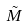<formula> <loc_0><loc_0><loc_500><loc_500>\tilde { M }</formula> 